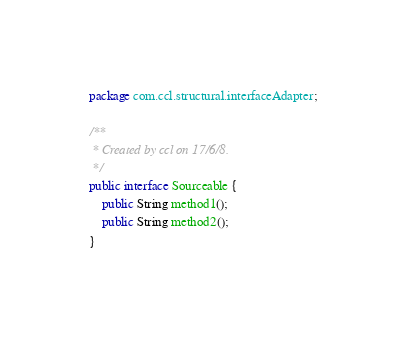<code> <loc_0><loc_0><loc_500><loc_500><_Java_>package com.ccl.structural.interfaceAdapter;

/**
 * Created by ccl on 17/6/8.
 */
public interface Sourceable {
    public String method1();
    public String method2();
}
</code> 